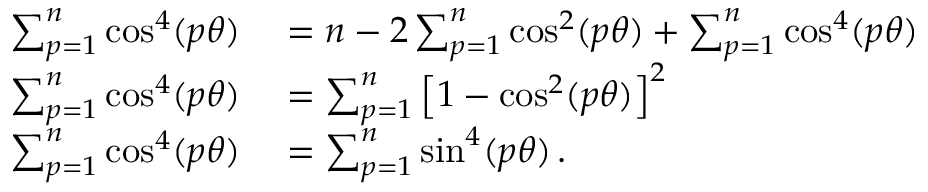Convert formula to latex. <formula><loc_0><loc_0><loc_500><loc_500>\begin{array} { r l } { \sum _ { p = 1 } ^ { n } \cos ^ { 4 } ( p \theta ) } & = n - 2 \sum _ { p = 1 } ^ { n } \cos ^ { 2 } ( p \theta ) + \sum _ { p = 1 } ^ { n } \cos ^ { 4 } ( p \theta ) \, } \\ { \sum _ { p = 1 } ^ { n } \cos ^ { 4 } ( p \theta ) } & = \sum _ { p = 1 } ^ { n } \left [ 1 - \cos ^ { 2 } ( p \theta ) \right ] ^ { 2 } \, } \\ { \sum _ { p = 1 } ^ { n } \cos ^ { 4 } ( p \theta ) } & = \sum _ { p = 1 } ^ { n } \sin ^ { 4 } ( p \theta ) \, . } \end{array}</formula> 